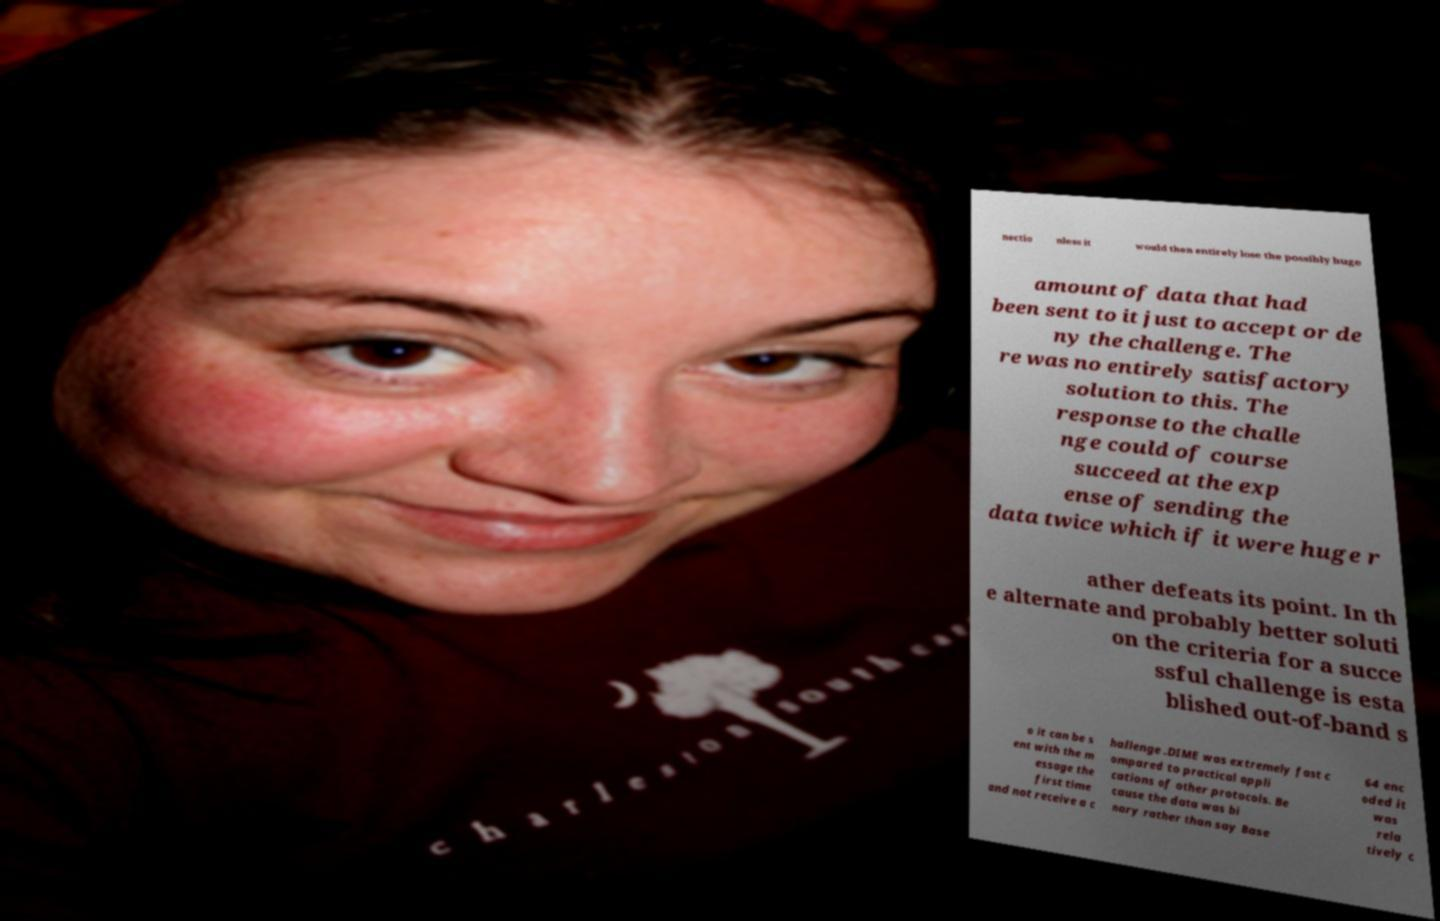Can you read and provide the text displayed in the image?This photo seems to have some interesting text. Can you extract and type it out for me? nectio nless it would then entirely lose the possibly huge amount of data that had been sent to it just to accept or de ny the challenge. The re was no entirely satisfactory solution to this. The response to the challe nge could of course succeed at the exp ense of sending the data twice which if it were huge r ather defeats its point. In th e alternate and probably better soluti on the criteria for a succe ssful challenge is esta blished out-of-band s o it can be s ent with the m essage the first time and not receive a c hallenge .DIME was extremely fast c ompared to practical appli cations of other protocols. Be cause the data was bi nary rather than say Base 64 enc oded it was rela tively c 